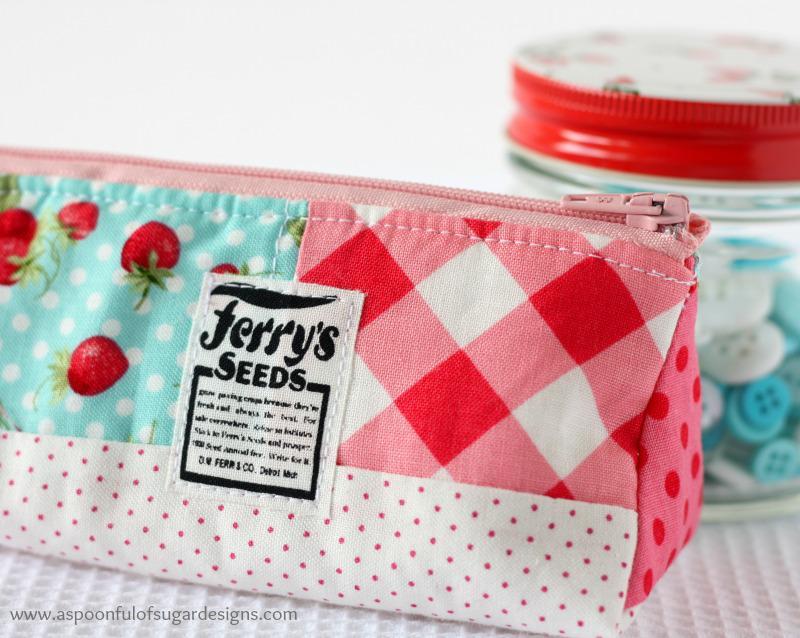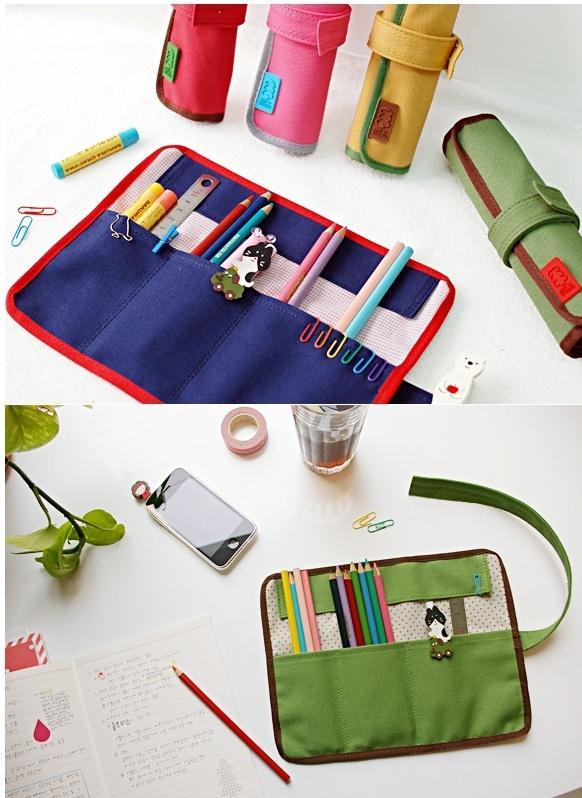The first image is the image on the left, the second image is the image on the right. Evaluate the accuracy of this statement regarding the images: "There are strawberries pictured on a total of 1 pencil case.". Is it true? Answer yes or no. Yes. The first image is the image on the left, the second image is the image on the right. Given the left and right images, does the statement "One image shows a pencil case lying on top of notepaper." hold true? Answer yes or no. No. 